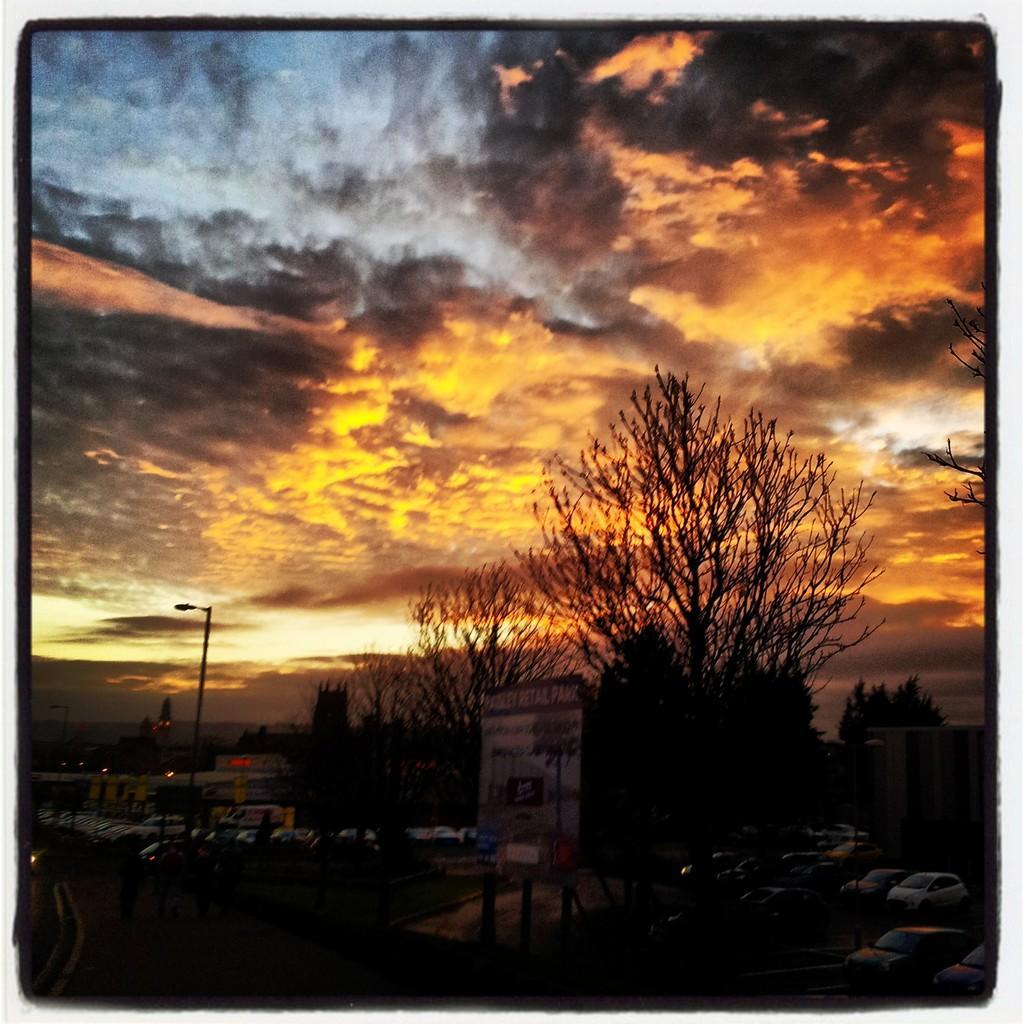Please provide a concise description of this image. In this picture I can see trees, buildings, few cars parked and a board with some text. I can see pole light on the left side and the sky. 